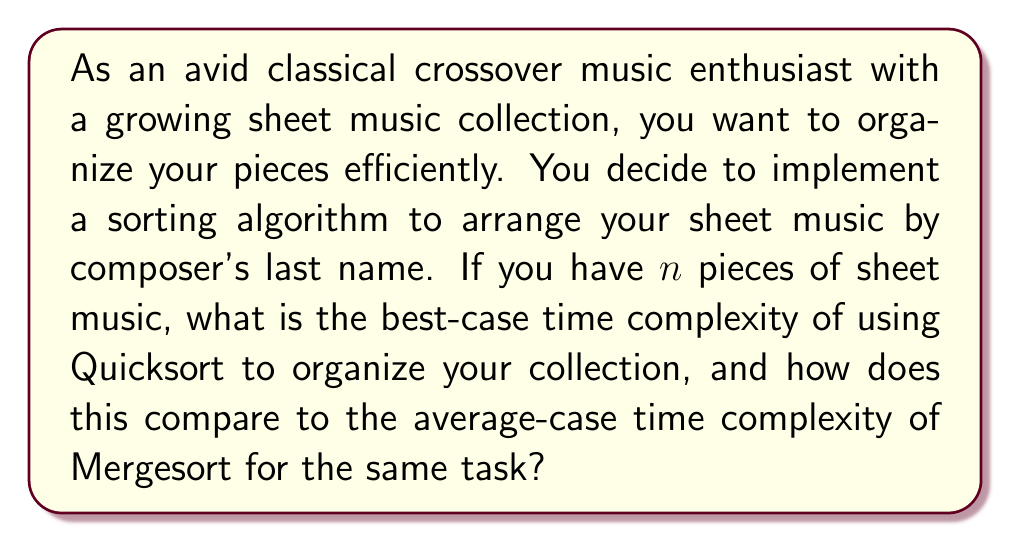Give your solution to this math problem. To answer this question, we need to analyze the time complexities of Quicksort and Mergesort:

1. Quicksort:
   - Best-case scenario: This occurs when the pivot chosen in each recursive step divides the array into two nearly equal halves.
   - In this case, the recurrence relation is: $T(n) = 2T(n/2) + O(n)$
   - Solving this recurrence using the Master Theorem yields: $O(n \log n)$

2. Mergesort:
   - Mergesort has a consistent time complexity regardless of the input order.
   - Its recurrence relation is always: $T(n) = 2T(n/2) + O(n)$
   - This also solves to $O(n \log n)$ using the Master Theorem.

For your sheet music collection:
- Quicksort's best-case: $O(n \log n)$
- Mergesort's average-case: $O(n \log n)$

Both algorithms have the same time complexity in these scenarios. However, it's worth noting that:
1. Quicksort's average-case is also $O(n \log n)$, but its worst-case is $O(n^2)$.
2. Mergesort consistently performs at $O(n \log n)$ for all cases.

In the context of organizing sheet music, both algorithms would perform similarly in the specified scenarios, sorting your $n$ pieces in $O(n \log n)$ time.
Answer: The best-case time complexity of Quicksort for organizing $n$ pieces of sheet music is $O(n \log n)$, which is the same as the average-case time complexity of Mergesort, $O(n \log n)$. 